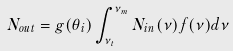Convert formula to latex. <formula><loc_0><loc_0><loc_500><loc_500>N _ { o u t } = g ( \theta _ { i } ) \int _ { \nu _ { t } } ^ { \nu _ { m } } N _ { i n } ( \nu ) f ( \nu ) d \nu</formula> 